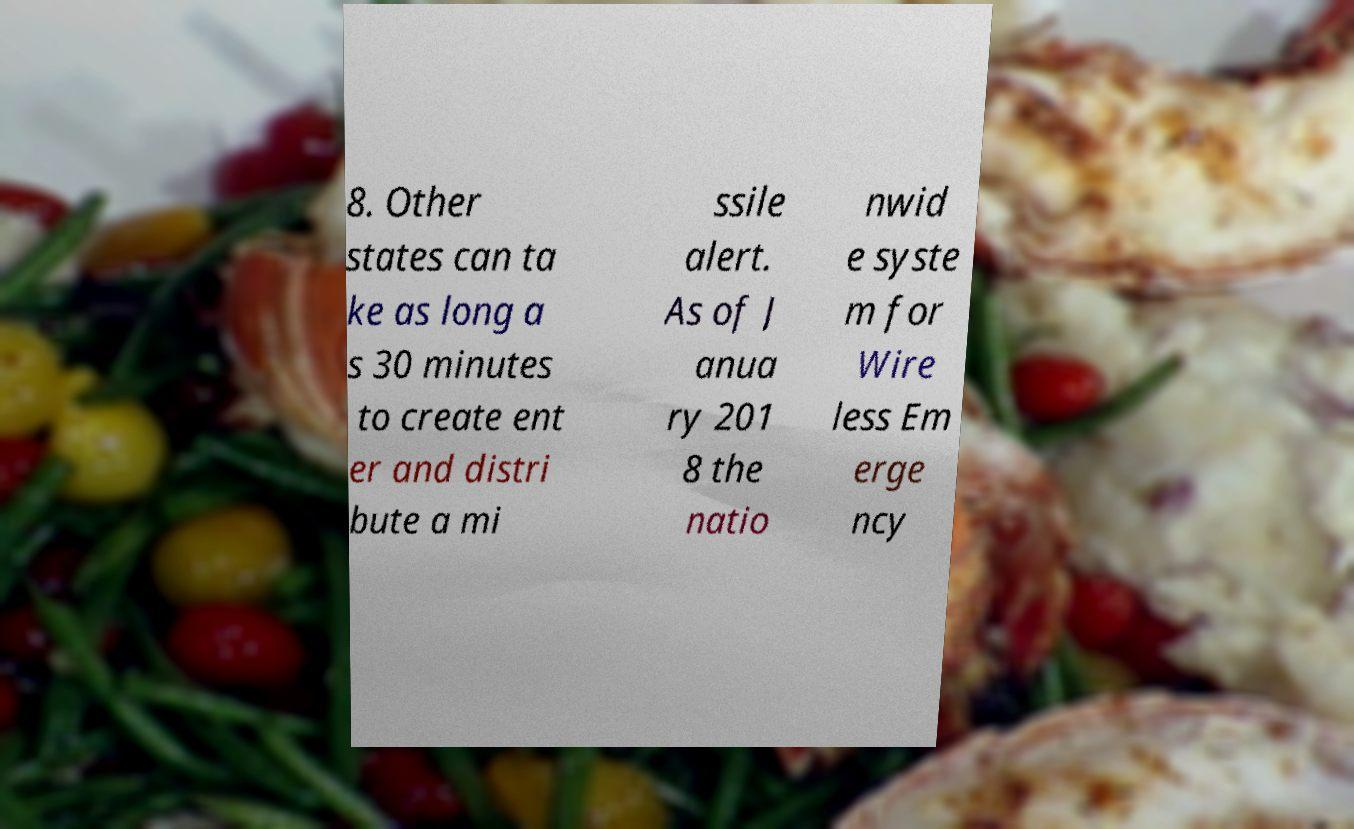Please identify and transcribe the text found in this image. 8. Other states can ta ke as long a s 30 minutes to create ent er and distri bute a mi ssile alert. As of J anua ry 201 8 the natio nwid e syste m for Wire less Em erge ncy 